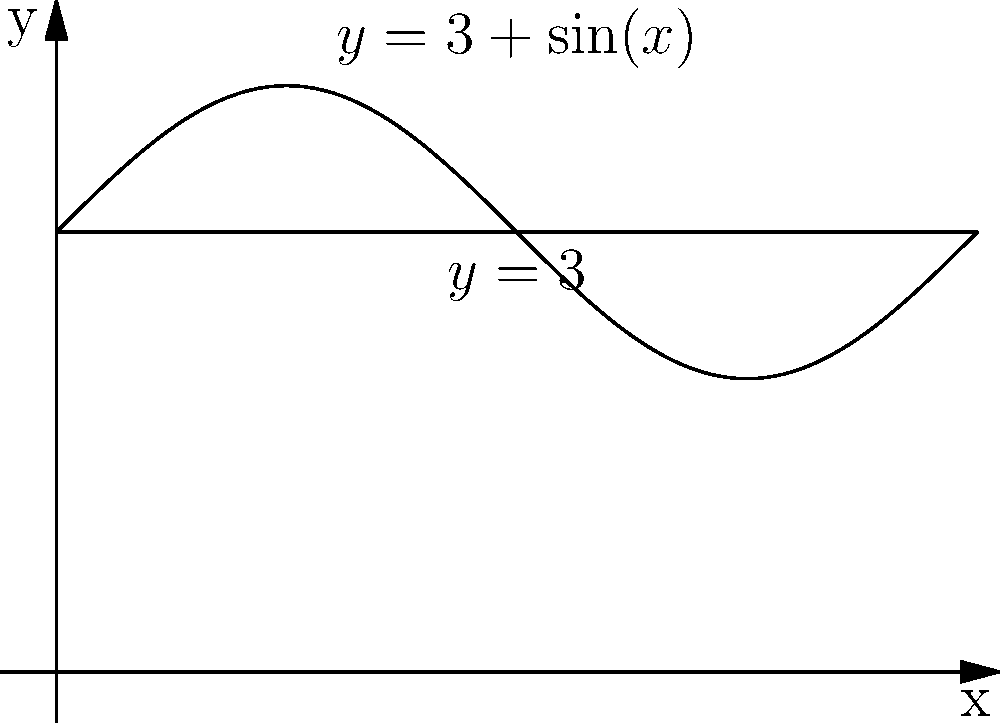As a dedicated fan of Fiona Ferro, you know she always carries her tennis balls in a special container. The container's shape is formed by revolving the region bounded by $y=3+\sin(x)$, $y=3$, and the y-axis from $x=0$ to $x=2\pi$ around the x-axis. Calculate the volume of this container in cubic units. To find the volume of the solid formed by revolving the given region around the x-axis, we'll use the washer method:

1) The volume is given by the formula:
   $$V = \pi \int_a^b [R(x)^2 - r(x)^2] dx$$
   where $R(x)$ is the outer function and $r(x)$ is the inner function.

2) In this case:
   $R(x) = 3 + \sin(x)$
   $r(x) = 3$
   $a = 0$ and $b = 2\pi$

3) Substituting into the formula:
   $$V = \pi \int_0^{2\pi} [(3+\sin(x))^2 - 3^2] dx$$

4) Simplify:
   $$V = \pi \int_0^{2\pi} [9+6\sin(x)+\sin^2(x) - 9] dx$$
   $$V = \pi \int_0^{2\pi} [6\sin(x)+\sin^2(x)] dx$$

5) Integrate:
   $$V = \pi [-6\cos(x) + \frac{x}{2} - \frac{\sin(2x)}{4}]_0^{2\pi}$$

6) Evaluate:
   $$V = \pi [(-6\cos(2\pi) + \pi - \frac{\sin(4\pi)}{4}) - (-6\cos(0) + 0 - \frac{\sin(0)}{4})]$$
   $$V = \pi [-6 + \pi - 0 - (-6 + 0 - 0)]$$
   $$V = \pi^2$$

Therefore, the volume of Fiona Ferro's special tennis ball container is $\pi^2$ cubic units.
Answer: $\pi^2$ cubic units 